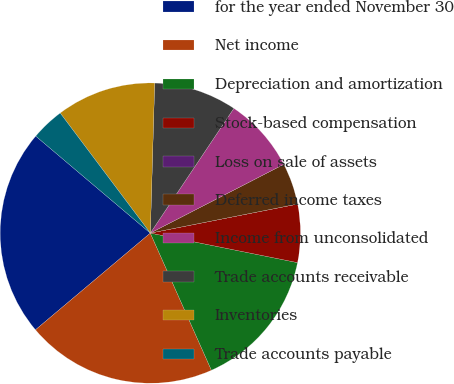Convert chart to OTSL. <chart><loc_0><loc_0><loc_500><loc_500><pie_chart><fcel>for the year ended November 30<fcel>Net income<fcel>Depreciation and amortization<fcel>Stock-based compensation<fcel>Loss on sale of assets<fcel>Deferred income taxes<fcel>Income from unconsolidated<fcel>Trade accounts receivable<fcel>Inventories<fcel>Trade accounts payable<nl><fcel>22.32%<fcel>20.53%<fcel>15.18%<fcel>6.25%<fcel>0.0%<fcel>4.47%<fcel>8.04%<fcel>8.93%<fcel>10.71%<fcel>3.57%<nl></chart> 